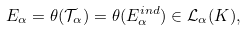<formula> <loc_0><loc_0><loc_500><loc_500>E _ { \alpha } = \theta ( \mathcal { T } _ { \alpha } ) = \theta ( E ^ { i n d } _ { \alpha } ) \in \mathcal { L } _ { \alpha } ( K ) ,</formula> 